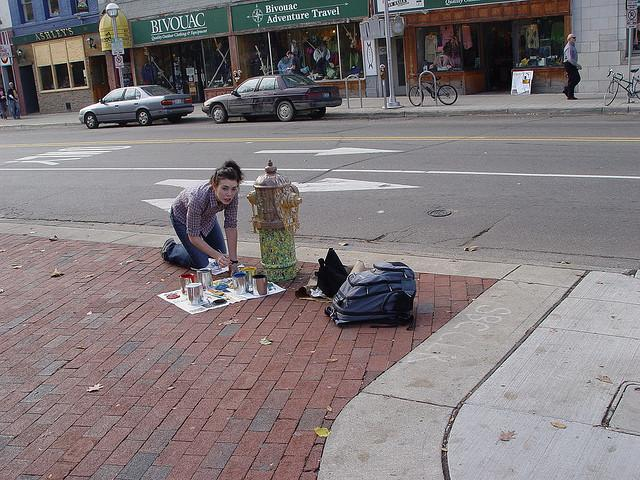What is the woman doing to the fire hydrant? Please explain your reasoning. painting it. The woman is painting. 